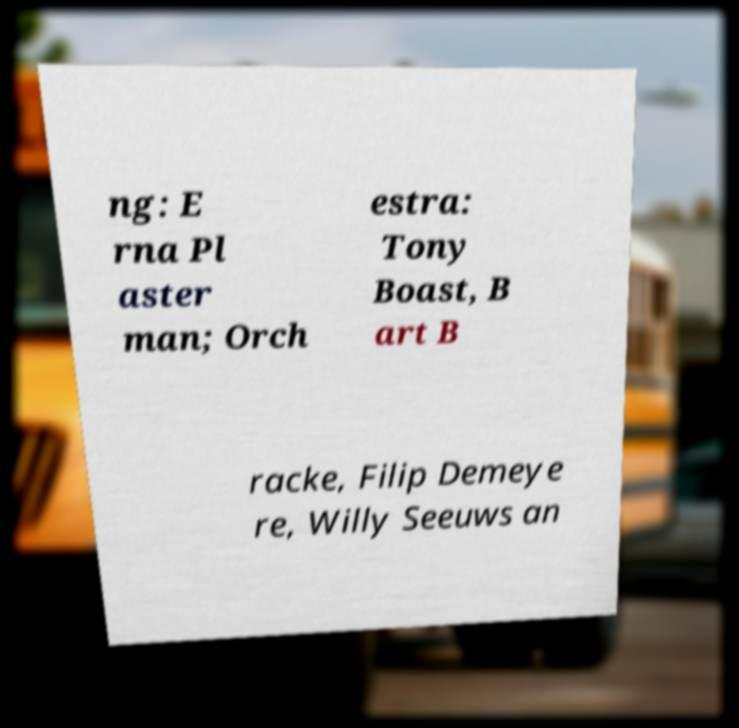Please identify and transcribe the text found in this image. ng: E rna Pl aster man; Orch estra: Tony Boast, B art B racke, Filip Demeye re, Willy Seeuws an 